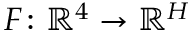<formula> <loc_0><loc_0><loc_500><loc_500>F \colon \mathbb { R } ^ { 4 } \rightarrow \mathbb { R } ^ { H }</formula> 